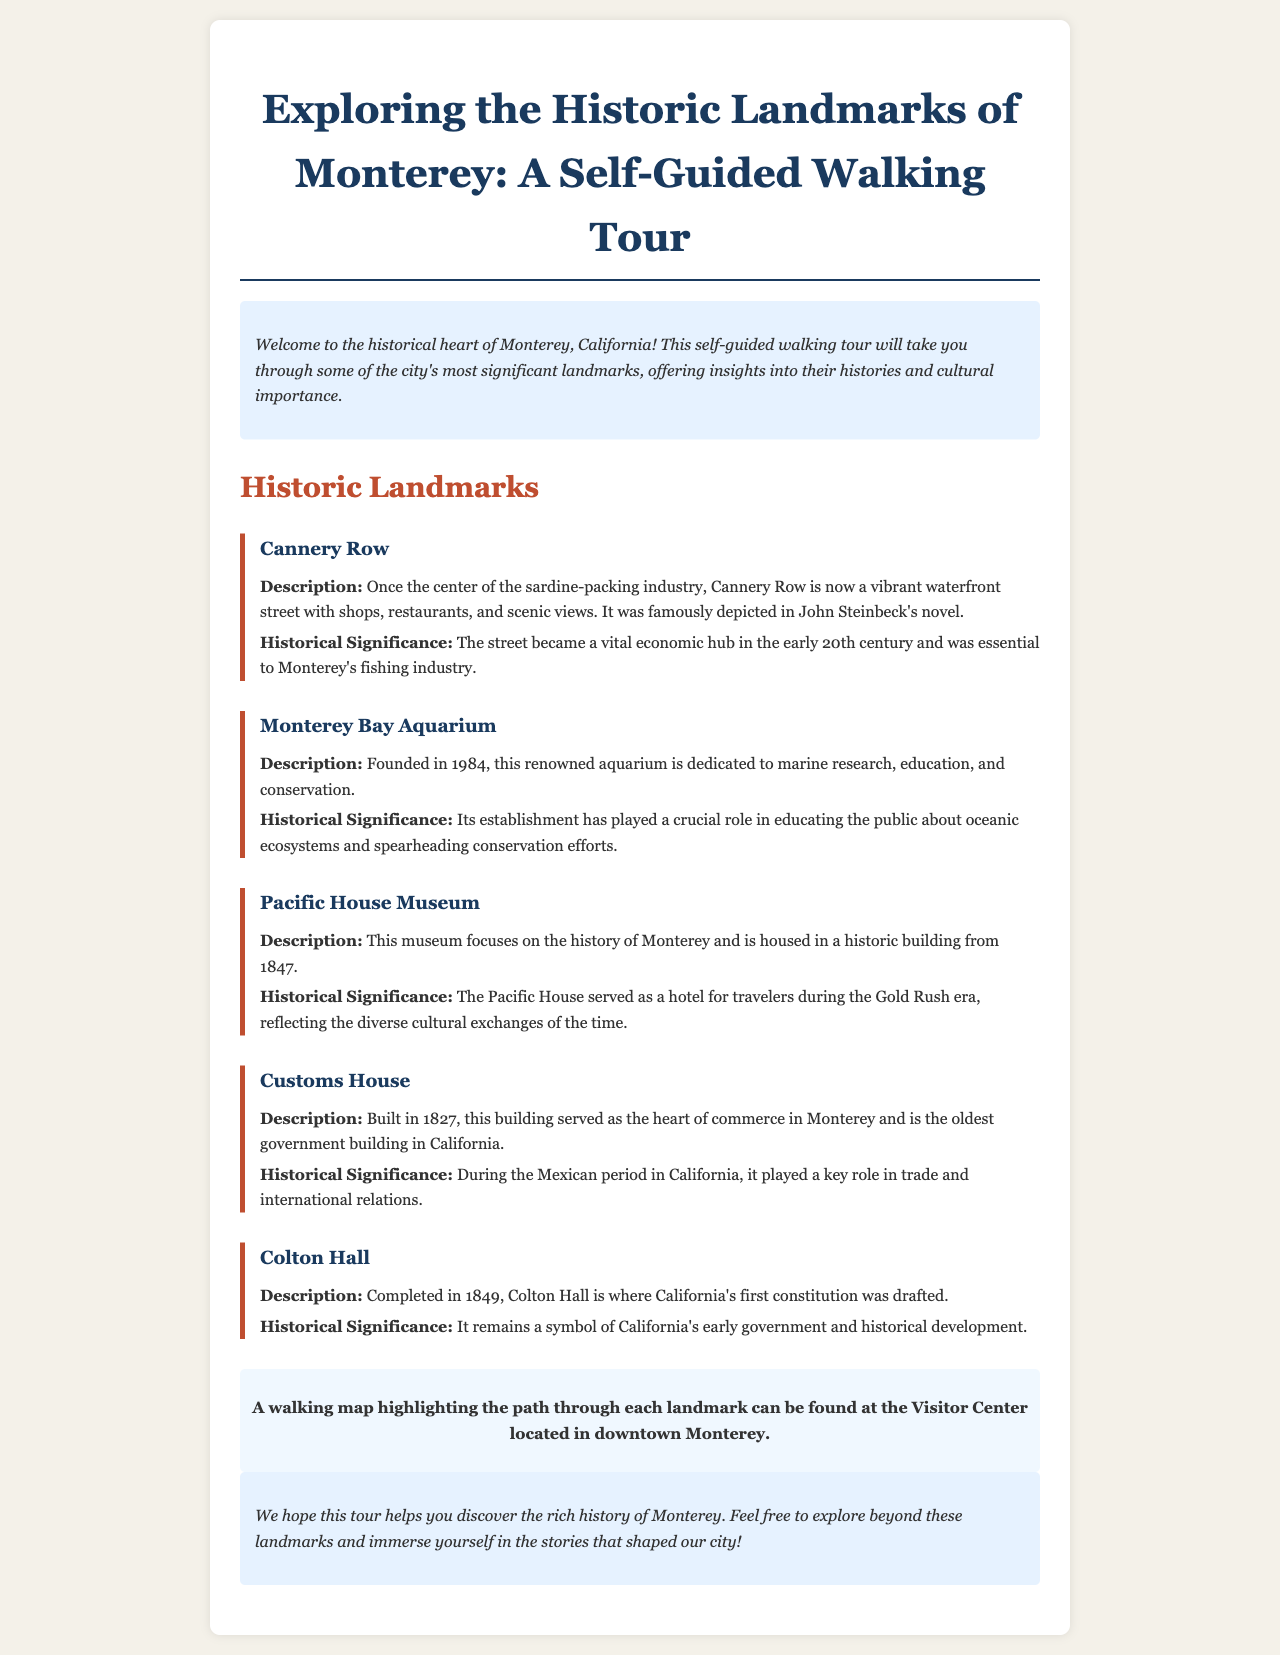What year was the Monterey Bay Aquarium founded? The document states that the Monterey Bay Aquarium was founded in 1984.
Answer: 1984 What is the oldest government building in California? The document mentions that the Customs House is the oldest government building in California.
Answer: Customs House What significant event occurred at Colton Hall? The document indicates that California's first constitution was drafted at Colton Hall.
Answer: Drafting of California's first constitution Which landmark served as a hotel during the Gold Rush era? The Pacific House Museum is highlighted in the document as having served as a hotel for travelers during the Gold Rush era.
Answer: Pacific House Museum What describes Cannery Row? According to the document, Cannery Row is described as a vibrant waterfront street with shops, restaurants, and scenic views.
Answer: Vibrant waterfront street What is the main focus of the Pacific House Museum? The document states that the museum focuses on the history of Monterey.
Answer: History of Monterey What type of information can be found at the Visitor Center? The document notes that a walking map highlighting the path through each landmark can be found at the Visitor Center.
Answer: Walking map Why is the Monterey Bay Aquarium significant? The aquarium's establishment has played a crucial role in educating the public about oceanic ecosystems and spearheading conservation efforts according to the document.
Answer: Education & conservation efforts What modern appeal does Cannery Row have today? The document describes Cannery Row today as having shops and restaurants, emphasizing its current vibrancy.
Answer: Shops and restaurants 